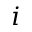Convert formula to latex. <formula><loc_0><loc_0><loc_500><loc_500>i</formula> 